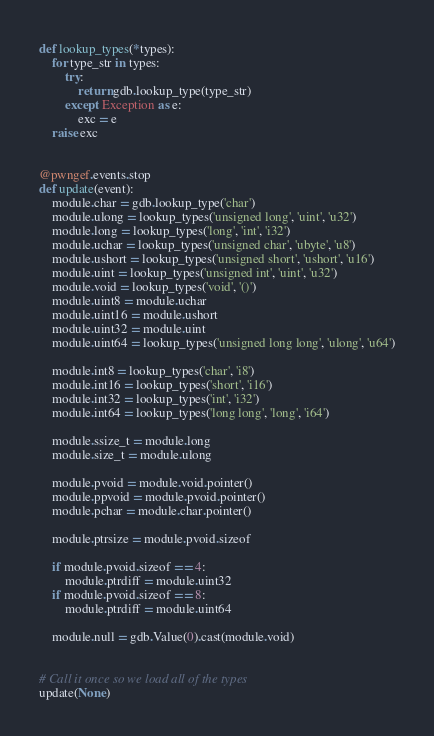<code> <loc_0><loc_0><loc_500><loc_500><_Python_>def lookup_types(*types):
    for type_str in types:
        try:
            return gdb.lookup_type(type_str)
        except Exception as e:
            exc = e
    raise exc


@pwngef.events.stop
def update(event):
    module.char = gdb.lookup_type('char')
    module.ulong = lookup_types('unsigned long', 'uint', 'u32')
    module.long = lookup_types('long', 'int', 'i32')
    module.uchar = lookup_types('unsigned char', 'ubyte', 'u8')
    module.ushort = lookup_types('unsigned short', 'ushort', 'u16')
    module.uint = lookup_types('unsigned int', 'uint', 'u32')
    module.void = lookup_types('void', '()')
    module.uint8 = module.uchar
    module.uint16 = module.ushort
    module.uint32 = module.uint
    module.uint64 = lookup_types('unsigned long long', 'ulong', 'u64')

    module.int8 = lookup_types('char', 'i8')
    module.int16 = lookup_types('short', 'i16')
    module.int32 = lookup_types('int', 'i32')
    module.int64 = lookup_types('long long', 'long', 'i64')

    module.ssize_t = module.long
    module.size_t = module.ulong

    module.pvoid = module.void.pointer()
    module.ppvoid = module.pvoid.pointer()
    module.pchar = module.char.pointer()

    module.ptrsize = module.pvoid.sizeof

    if module.pvoid.sizeof == 4:
        module.ptrdiff = module.uint32
    if module.pvoid.sizeof == 8:
        module.ptrdiff = module.uint64

    module.null = gdb.Value(0).cast(module.void)


# Call it once so we load all of the types
update(None)
</code> 